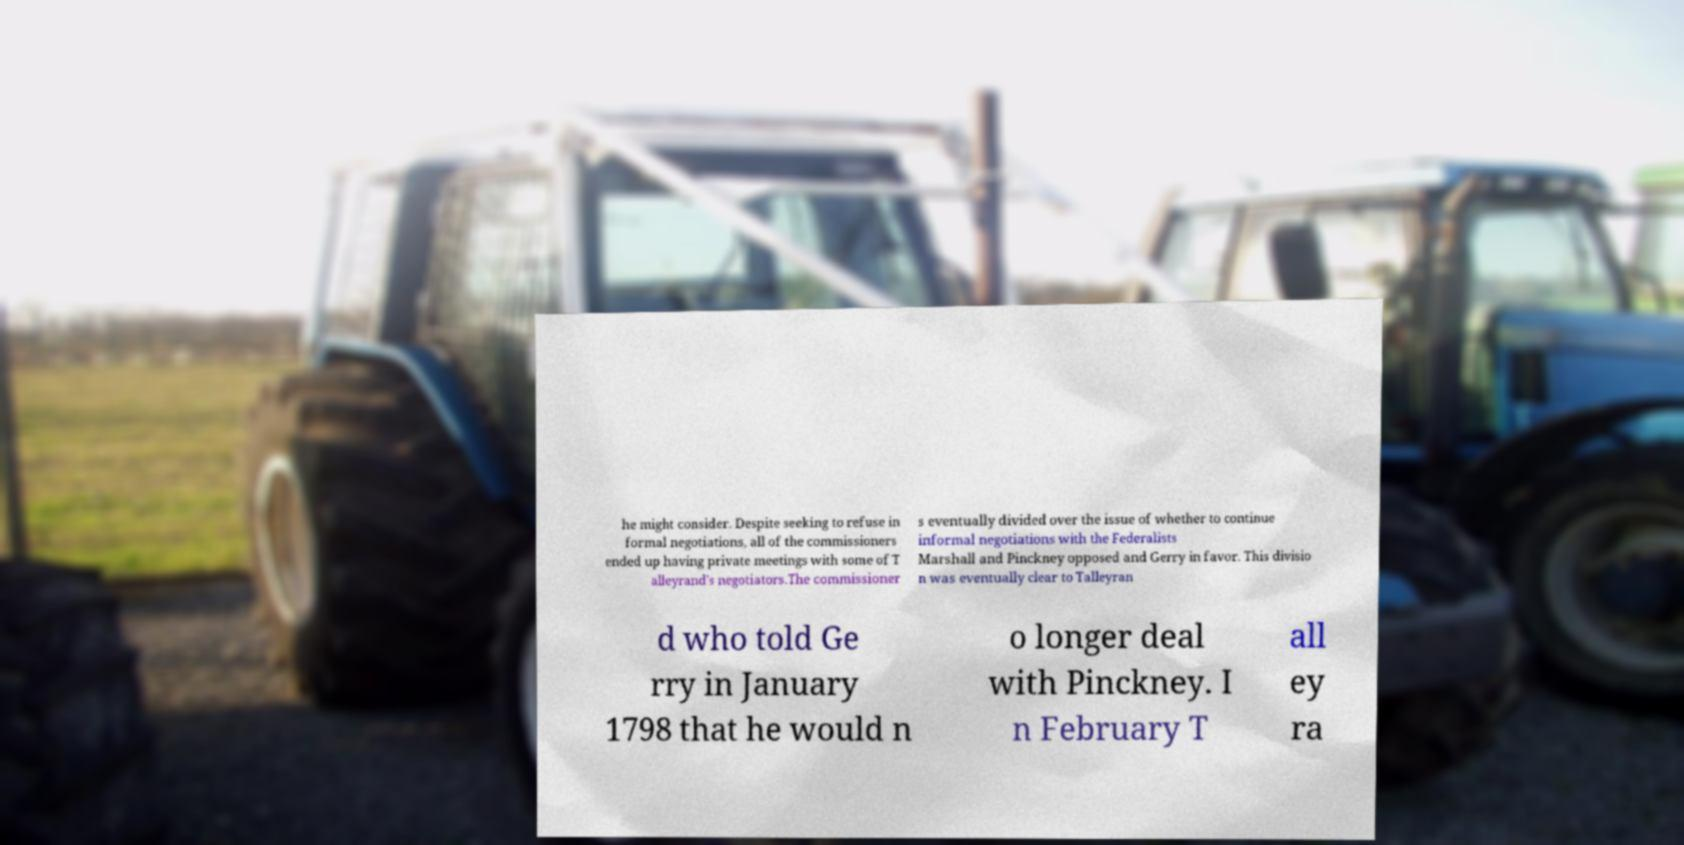There's text embedded in this image that I need extracted. Can you transcribe it verbatim? he might consider. Despite seeking to refuse in formal negotiations, all of the commissioners ended up having private meetings with some of T alleyrand's negotiators.The commissioner s eventually divided over the issue of whether to continue informal negotiations with the Federalists Marshall and Pinckney opposed and Gerry in favor. This divisio n was eventually clear to Talleyran d who told Ge rry in January 1798 that he would n o longer deal with Pinckney. I n February T all ey ra 